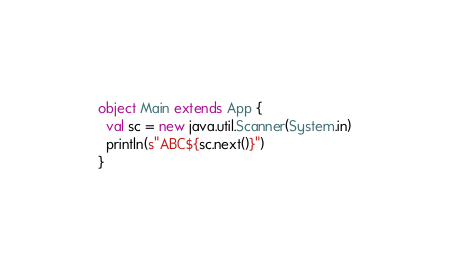<code> <loc_0><loc_0><loc_500><loc_500><_Scala_>object Main extends App {
  val sc = new java.util.Scanner(System.in)
  println(s"ABC${sc.next()}")
}
</code> 